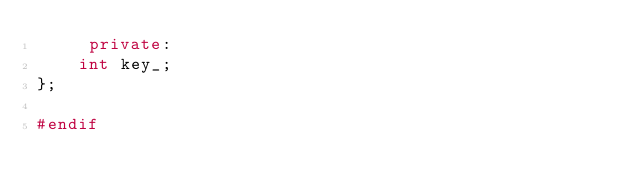Convert code to text. <code><loc_0><loc_0><loc_500><loc_500><_C++_>     private:
	int key_;
};

#endif
</code> 